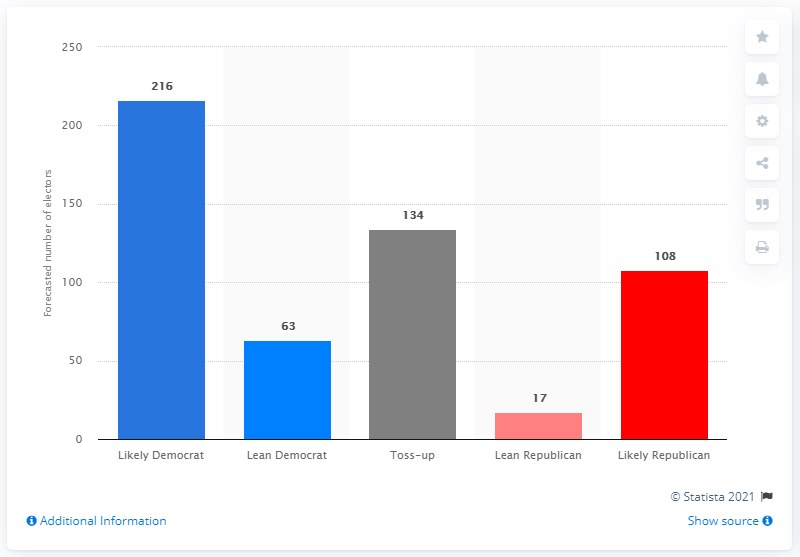Give some essential details in this illustration. Out of a total of 134 votes, there existed a close contest between Joe Biden and Joe Biden, with the outcome uncertain. 